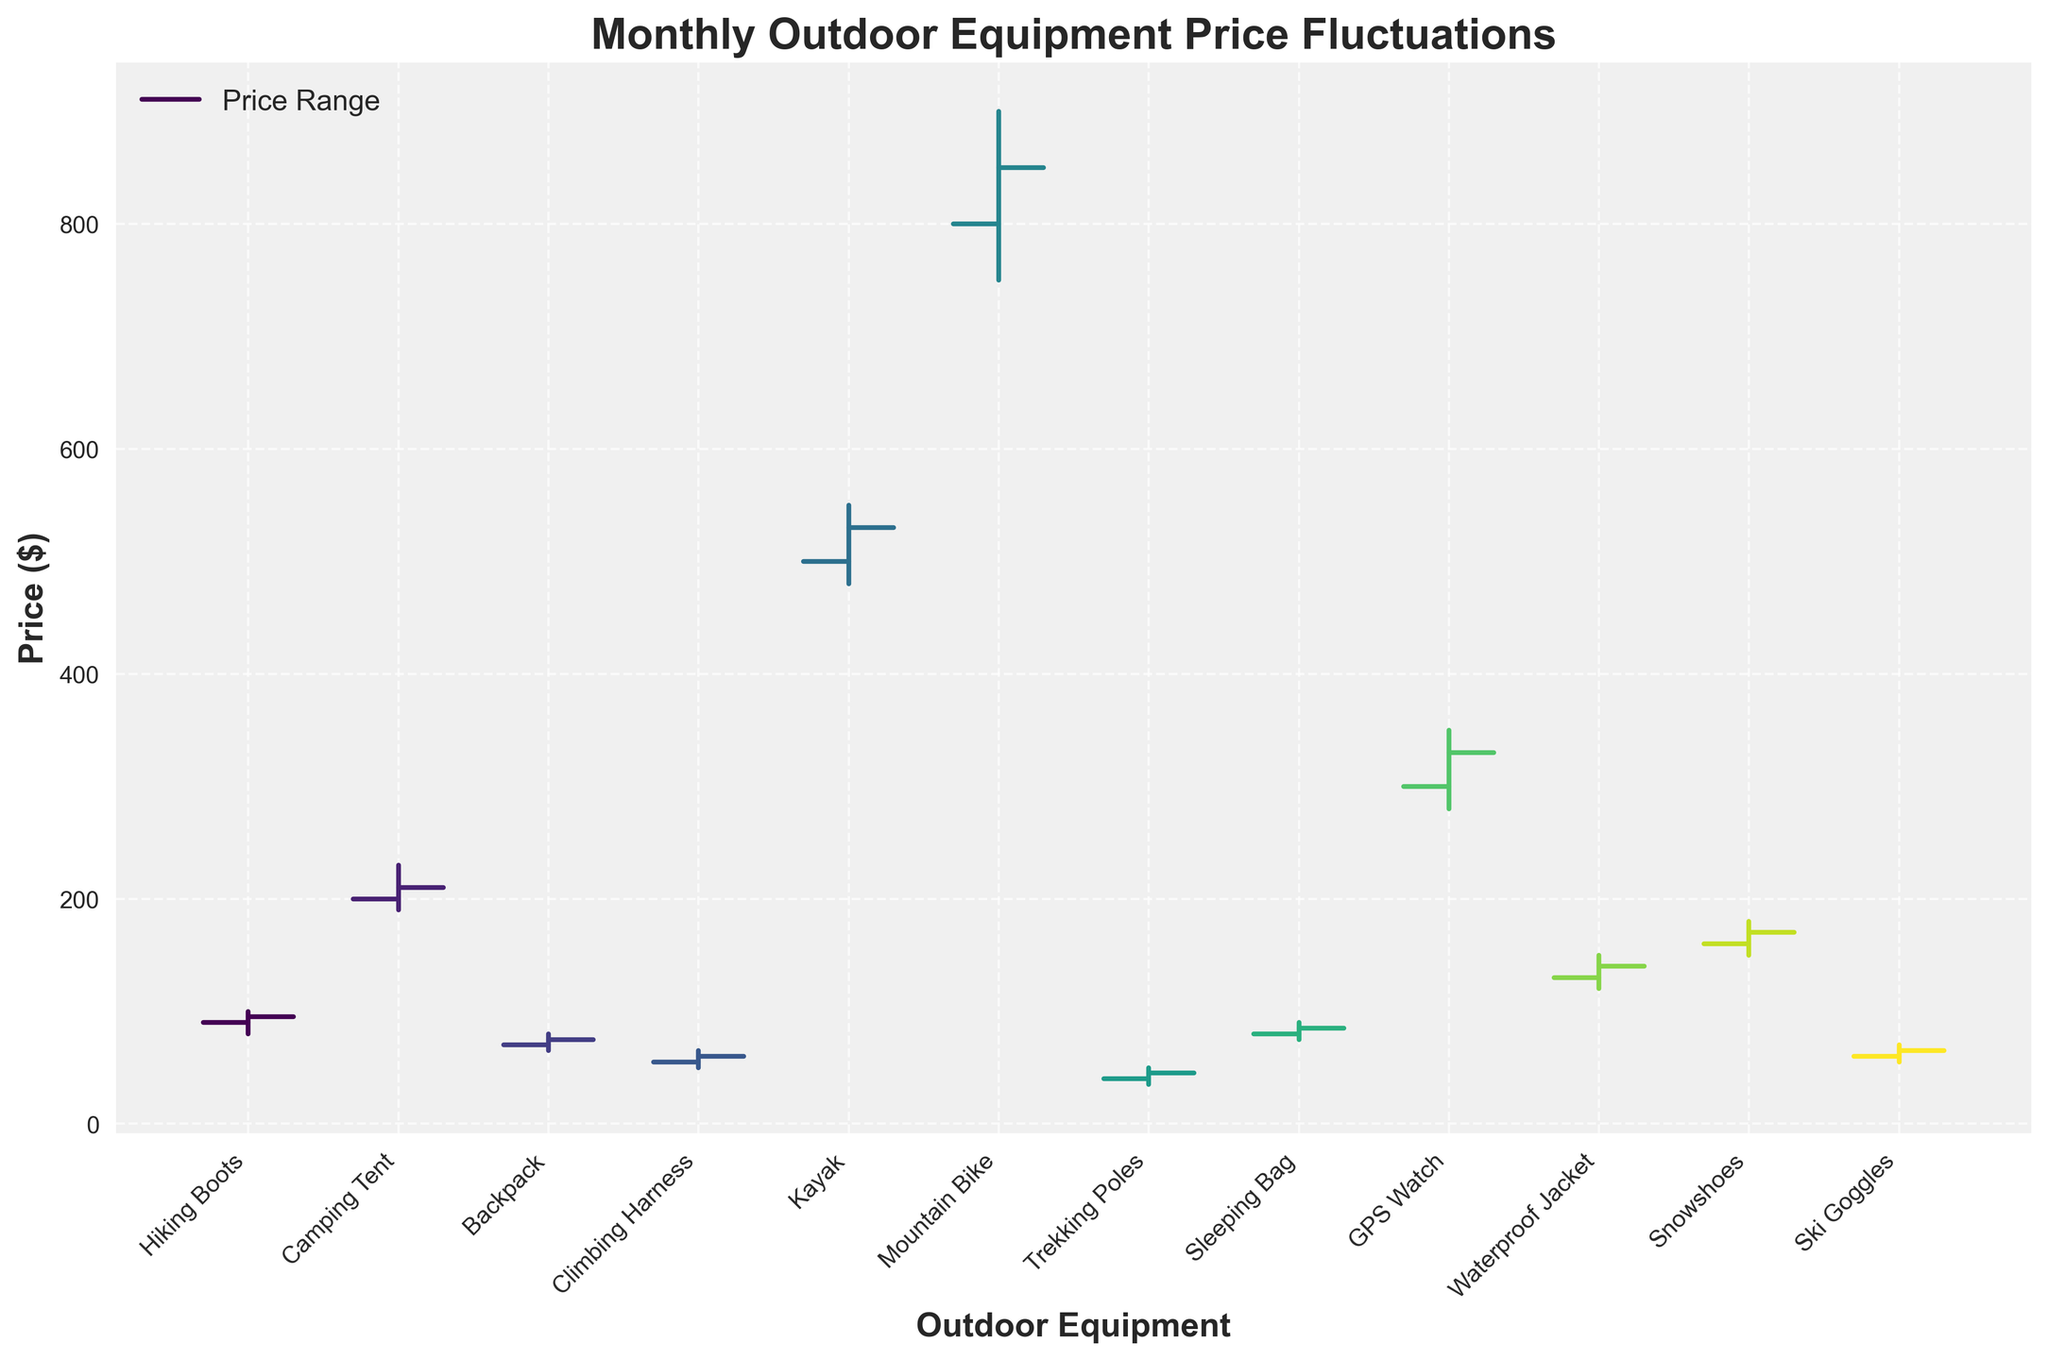What is the highest price observed in the data? Looking at the highest price values for each item, the maximum is $899.99 for the Mountain Bike in June.
Answer: $899.99 What month had the lowest opening price for outdoor equipment? Reviewing the "Open" column, the lowest opening price is $39.99 for Trekking Poles in July.
Answer: July Which item experienced the greatest range in price during its month? The range is determined by the difference between the high and low prices. Calculating this for each item, the Mountain Bike in June has the greatest range of $899.99 - $749.99 = $150.00.
Answer: Mountain Bike How many items had a closing price higher than the opening price? We need to compare the open and close prices for each item. Hiking Boots, Camping Tent, Backpack, Climbing Harness, Kayak, Mountain Bike, Trekking Poles, and Sleeping Bag all have closing prices higher than their opening prices. There are 8 such items.
Answer: 8 Which month showed the largest drop in price from open to close? Calculate the difference (open - close) for each month and identify the maximum. For example, for Hiking Boots in January: $89.99 - $94.99 = -$5.00 (price increased), for Camping Tent in February: $199.99 - $209.99 = -$10.00 (price increased), etc. The largest drop is for the GPS Watch in September: $299.99 - $329.99 = -$30.00.
Answer: GPS Watch What is the average opening price of all items? Sum all opening prices and divide by the number of items: (89.99 + 199.99 + 69.99 + 54.99 + 499.99 + 799.99 + 39.99 + 79.99 + 299.99 + 129.99 + 159.99 + 59.99) / 12 = 209.15.
Answer: $209.15 Which item had the smallest difference between its highest and lowest prices? Calculate the differences between high and low for each item and find the minimum. For example, Hiking Boots difference: $99.99 - $79.99 = $20.00. Repeating for all items, the smallest difference is for Trekking Poles at $49.99 - $34.99 = $15.00.
Answer: Trekking Poles How many items had their highest price above $300? Identify items whose high price exceeds $300. These items are Camping Tent, Kayak, Mountain Bike, and GPS Watch. There are 4 such items.
Answer: 4 Which month recorded the highest closing price? Comparing the closing prices, the Mountain Bike in June has the highest closing price of $849.99.
Answer: June 